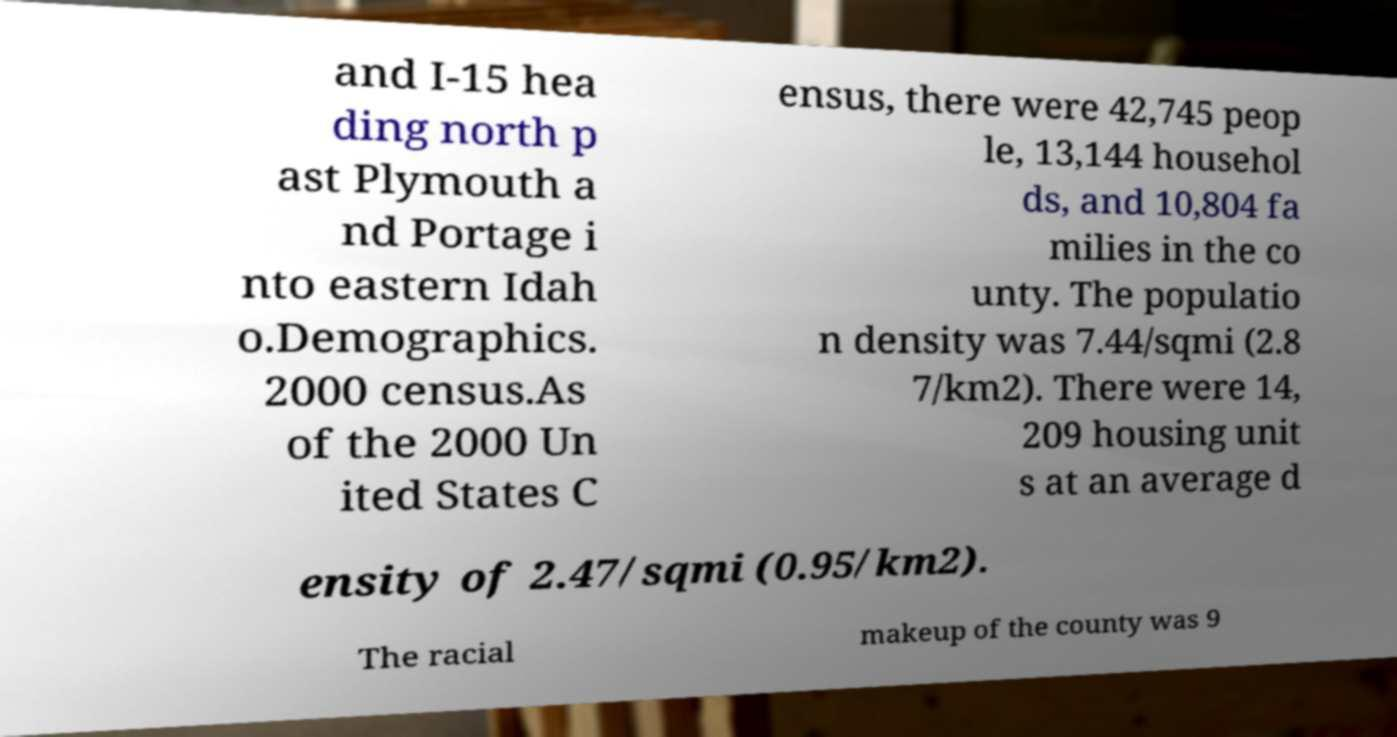I need the written content from this picture converted into text. Can you do that? and I-15 hea ding north p ast Plymouth a nd Portage i nto eastern Idah o.Demographics. 2000 census.As of the 2000 Un ited States C ensus, there were 42,745 peop le, 13,144 househol ds, and 10,804 fa milies in the co unty. The populatio n density was 7.44/sqmi (2.8 7/km2). There were 14, 209 housing unit s at an average d ensity of 2.47/sqmi (0.95/km2). The racial makeup of the county was 9 